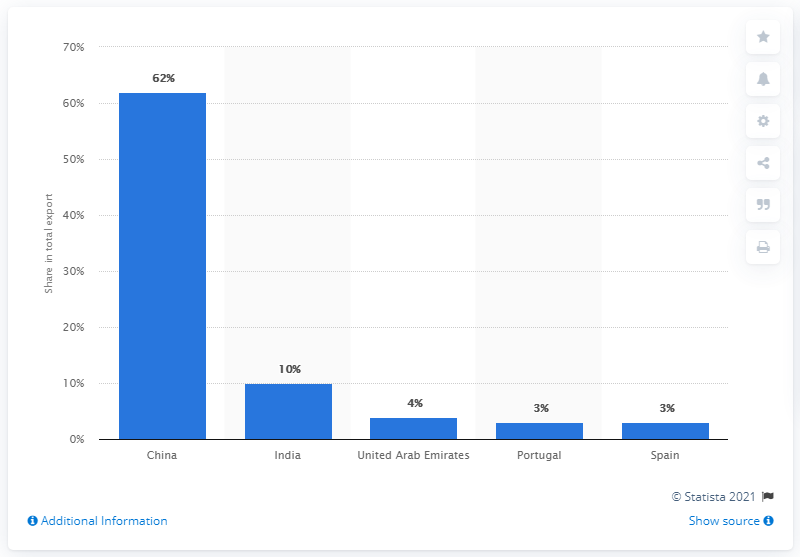Specify some key components in this picture. In 2019, China was Angola's most significant export partner, playing a crucial role in the country's economic development. 